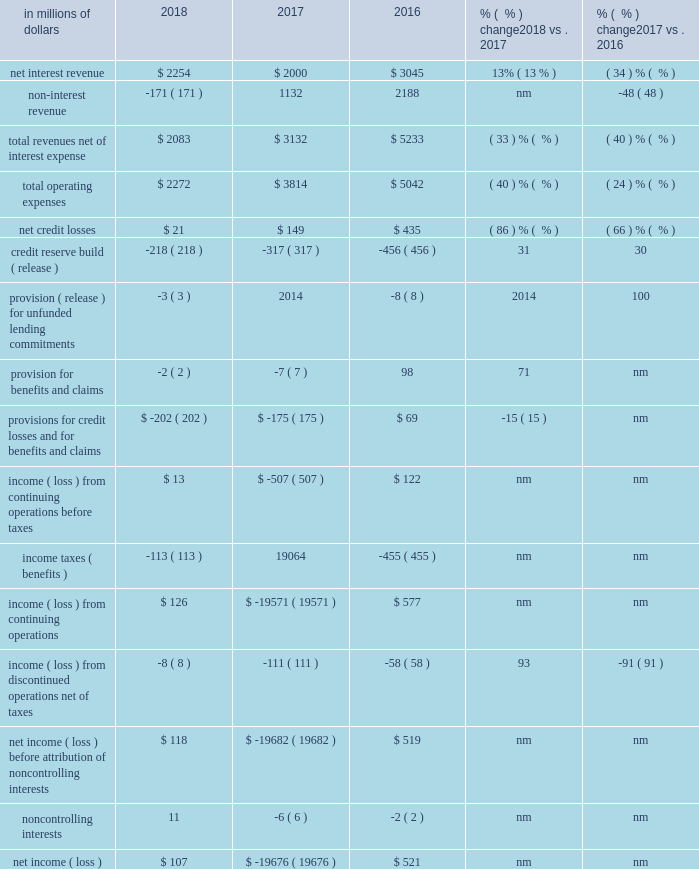Corporate/other corporate/other includes certain unallocated costs of global staff functions ( including finance , risk , human resources , legal and compliance ) , other corporate expenses and unallocated global operations and technology expenses and income taxes , as well as corporate treasury , certain north america legacy consumer loan portfolios , other legacy assets and discontinued operations ( for additional information on corporate/other , see 201ccitigroup segments 201d above ) .
At december 31 , 2018 , corporate/other had $ 91 billion in assets , an increase of 17% ( 17 % ) from the prior year .
In millions of dollars 2018 2017 2016 % (  % ) change 2018 vs .
2017 % (  % ) change 2017 vs .
2016 .
Nm not meaningful 2018 vs .
2017 net income was $ 107 million in 2018 , compared to a net loss of $ 19.7 billion in the prior year , primarily driven by the $ 19.8 billion one-time , non-cash charge recorded in the tax line in 2017 due to the impact of tax reform .
Results in 2018 included the one-time benefit of $ 94 million in the tax line , related to tax reform .
For additional information , see 201csignificant accounting policies and significant estimates 2014income taxes 201d below .
Excluding the one-time impact of tax reform in 2018 and 2017 , net income decreased 92% ( 92 % ) , reflecting lower revenues , partially offset by lower expenses , lower cost of credit and tax benefits related to the reorganization of certain non-u.s .
Subsidiaries .
The tax benefits were largely offset by the release of a foreign currency translation adjustment ( cta ) from aoci to earnings ( for additional information on the cta release , see note 19 to the consolidated financial statements ) .
Revenues decreased 33% ( 33 % ) , driven by the continued wind-down of legacy assets .
Expenses decreased 40% ( 40 % ) , primarily driven by the wind-down of legacy assets , lower infrastructure costs and lower legal expenses .
Provisions decreased $ 27 million to a net benefit of $ 202 million , primarily due to lower net credit losses , partially offset by a lower net loan loss reserve release .
Net credit losses declined 86% ( 86 % ) to $ 21 million , primarily reflecting the impact of ongoing divestiture activity and the continued wind-down of the north america mortgage portfolio .
The net reserve release declined by $ 96 million to $ 221 million , and reflected the continued wind-down of the legacy north america mortgage portfolio and divestitures .
2017 vs .
2016 the net loss was $ 19.7 billion , compared to net income of $ 521 million in the prior year , primarily driven by the one-time impact of tax reform .
Excluding the one-time impact of tax reform , net income declined 69% ( 69 % ) to $ 168 million , reflecting lower revenues , partially offset by lower expenses and lower cost of credit .
Revenues declined 40% ( 40 % ) , primarily reflecting the continued wind-down of legacy assets and the absence of gains related to debt buybacks in 2016 .
Revenues included approximately $ 750 million in gains on asset sales in the first quarter of 2017 , which more than offset a roughly $ 300 million charge related to the exit of citi 2019s u.s .
Mortgage servicing operations in the quarter .
Expenses declined 24% ( 24 % ) , reflecting the wind-down of legacy assets and lower legal expenses , partially offset by approximately $ 100 million in episodic expenses primarily related to the exit of the u.s .
Mortgage servicing operations .
Also included in expenses is an approximately $ 255 million provision for remediation costs related to a card act matter in 2017 .
Provisions decreased $ 244 million to a net benefit of $ 175 million , primarily due to lower net credit losses and a lower provision for benefits and claims , partially offset by a lower net loan loss reserve release .
Net credit losses declined 66% ( 66 % ) , primarily reflecting the impact of ongoing divestiture activity and the continued wind-down of the north america mortgage portfolio .
The decline in the provision for benefits and claims was primarily due to lower insurance activity .
The net reserve release declined $ 147 million , and reflected the continued wind-down of the legacy north america mortgage portfolio and divestitures. .
What was the percentage change in total revenues net of interest expense between 2016 and 2018? 
Computations: ((2083 - 5233) / 5233)
Answer: -0.60195. 